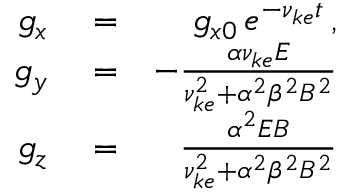Convert formula to latex. <formula><loc_0><loc_0><loc_500><loc_500>\begin{array} { r l r } { g _ { x } } & = } & { g _ { x 0 } \, e ^ { - \nu _ { k e } t } \, , } \\ { g _ { y } } & = } & { - \frac { \alpha \nu _ { k e } E } { \nu _ { k e } ^ { 2 } + \alpha ^ { 2 } \beta ^ { 2 } B ^ { 2 } } } \\ { g _ { z } } & = } & { \frac { \alpha ^ { 2 } E B } { \nu _ { k e } ^ { 2 } + \alpha ^ { 2 } \beta ^ { 2 } B ^ { 2 } } } \end{array}</formula> 